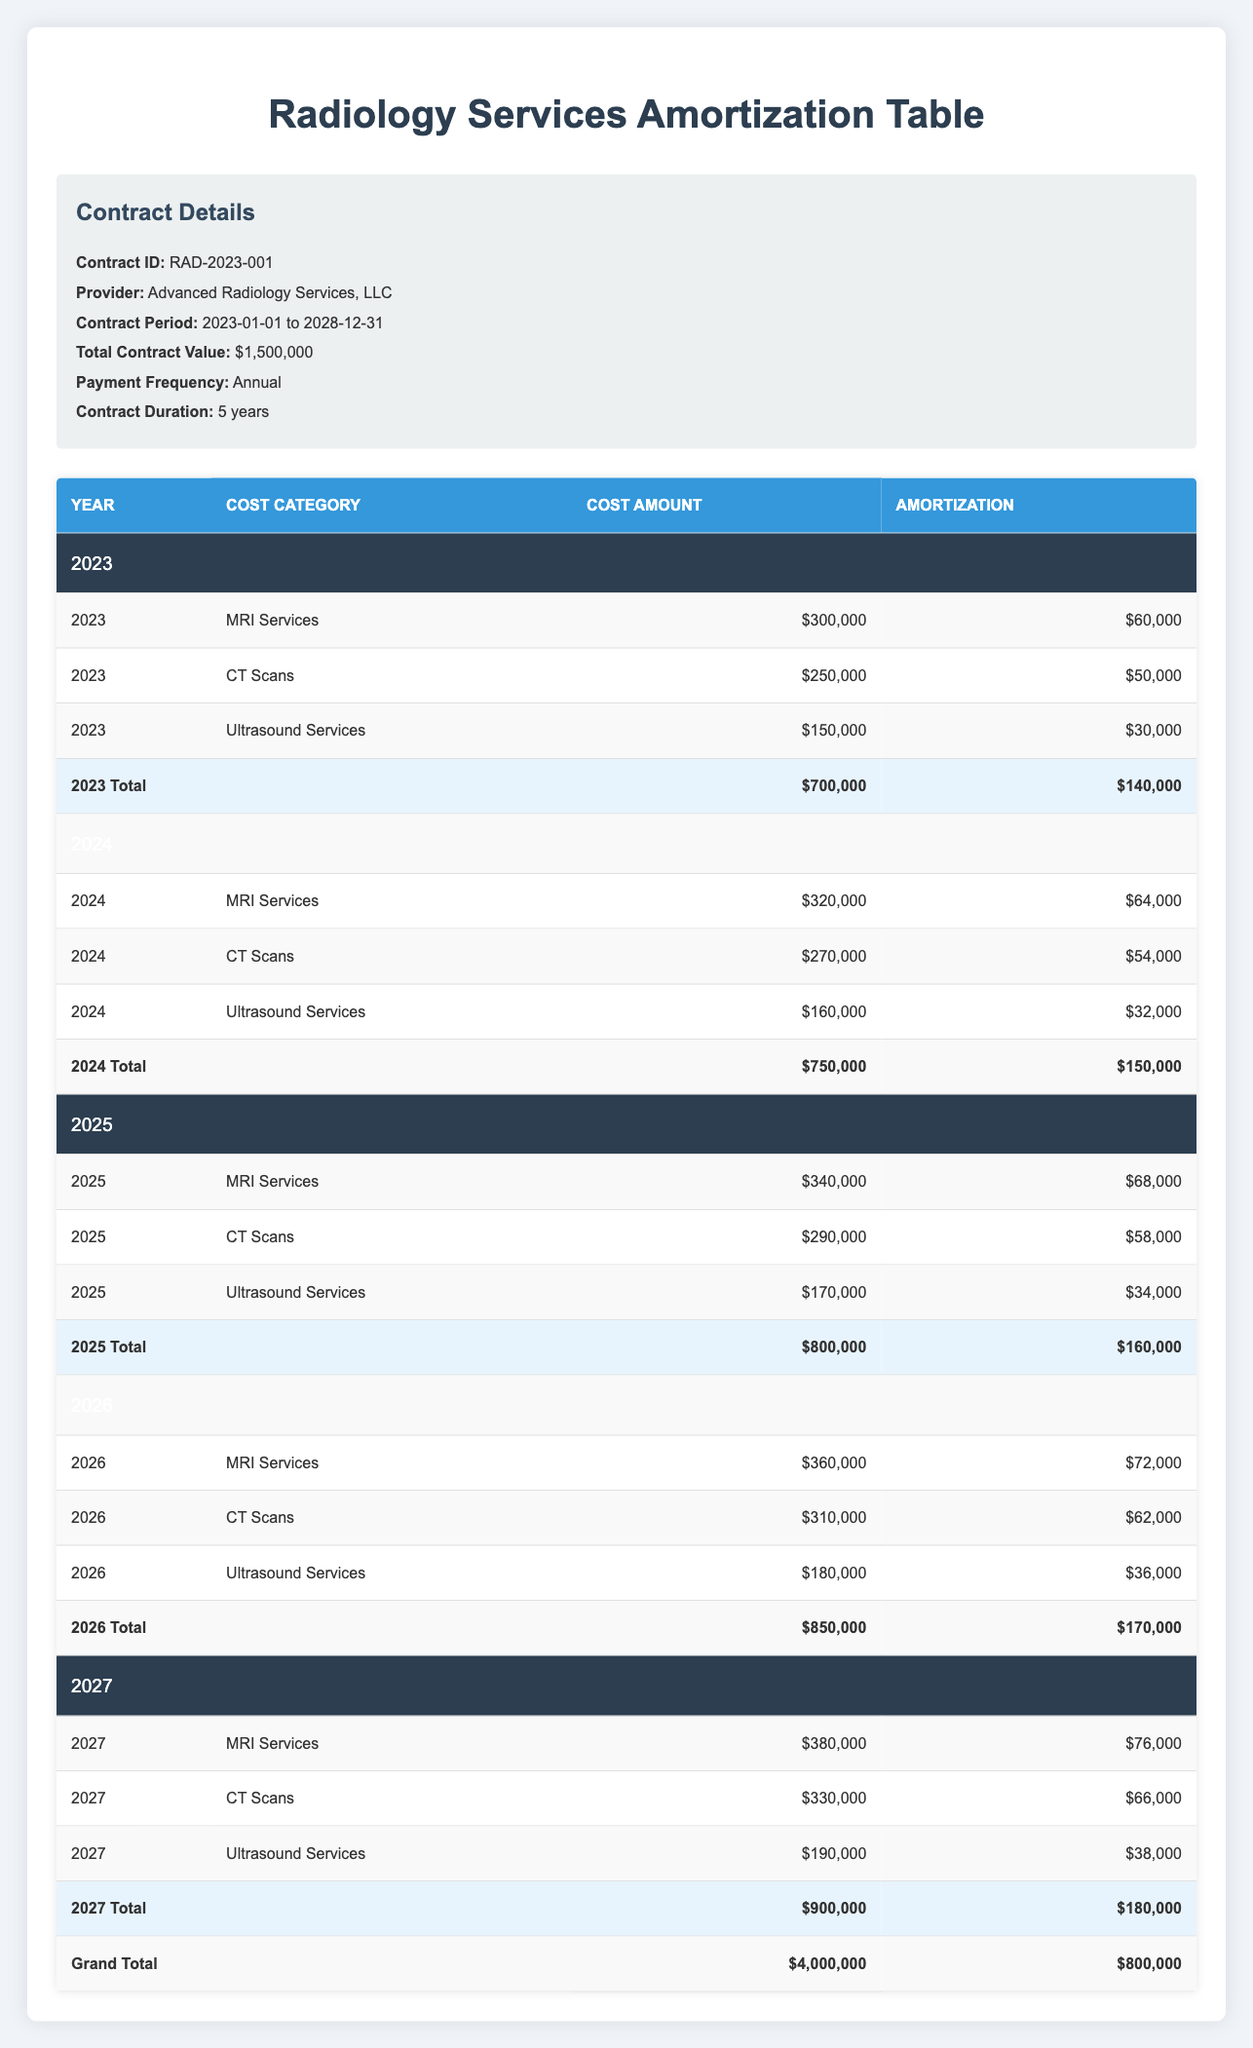What is the total cost amount for MRI Services in 2025? To find the total cost amount for MRI Services in 2025, I need to look at the row for 2025 under the cost category for MRI Services. The cost amount listed is $340,000.
Answer: 340,000 What is the total amortization for the year 2026? I will sum the amortization values for all cost categories in the year 2026. They are $72,000 (MRI Services) + $62,000 (CT Scans) + $36,000 (Ultrasound Services) = $170,000.
Answer: 170,000 Is the cost amount for CT Scans in 2024 greater than that in 2023? The cost amount for CT Scans in 2024 is $270,000 and in 2023 it is $250,000. Since $270,000 is greater than $250,000, the answer is yes.
Answer: Yes What is the average annual amortization across all years? I need to compute the total amortization for each year and then divide that sum by the number of years (5). The total amortization values are: 140,000 + 150,000 + 160,000 + 170,000 + 180,000 = 800,000. The average is 800,000 / 5 = 160,000.
Answer: 160,000 In which year did the total cost amount exceed $800,000 for the first time? I will look at the total cost amounts by year. The values are: 2023 = 700,000, 2024 = 750,000, 2025 = 800,000, and 2026 = 850,000. The total cost amount first exceeds $800,000 in 2026.
Answer: 2026 